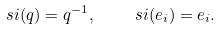Convert formula to latex. <formula><loc_0><loc_0><loc_500><loc_500>\ s i ( q ) = q ^ { - 1 } , \quad \ s i ( e _ { i } ) = e _ { i } .</formula> 